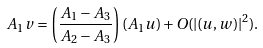<formula> <loc_0><loc_0><loc_500><loc_500>A _ { 1 } v & = \left ( \frac { A _ { 1 } - A _ { 3 } } { A _ { 2 } - A _ { 3 } } \right ) ( A _ { 1 } u ) + O ( | ( u , w ) | ^ { 2 } ) .</formula> 